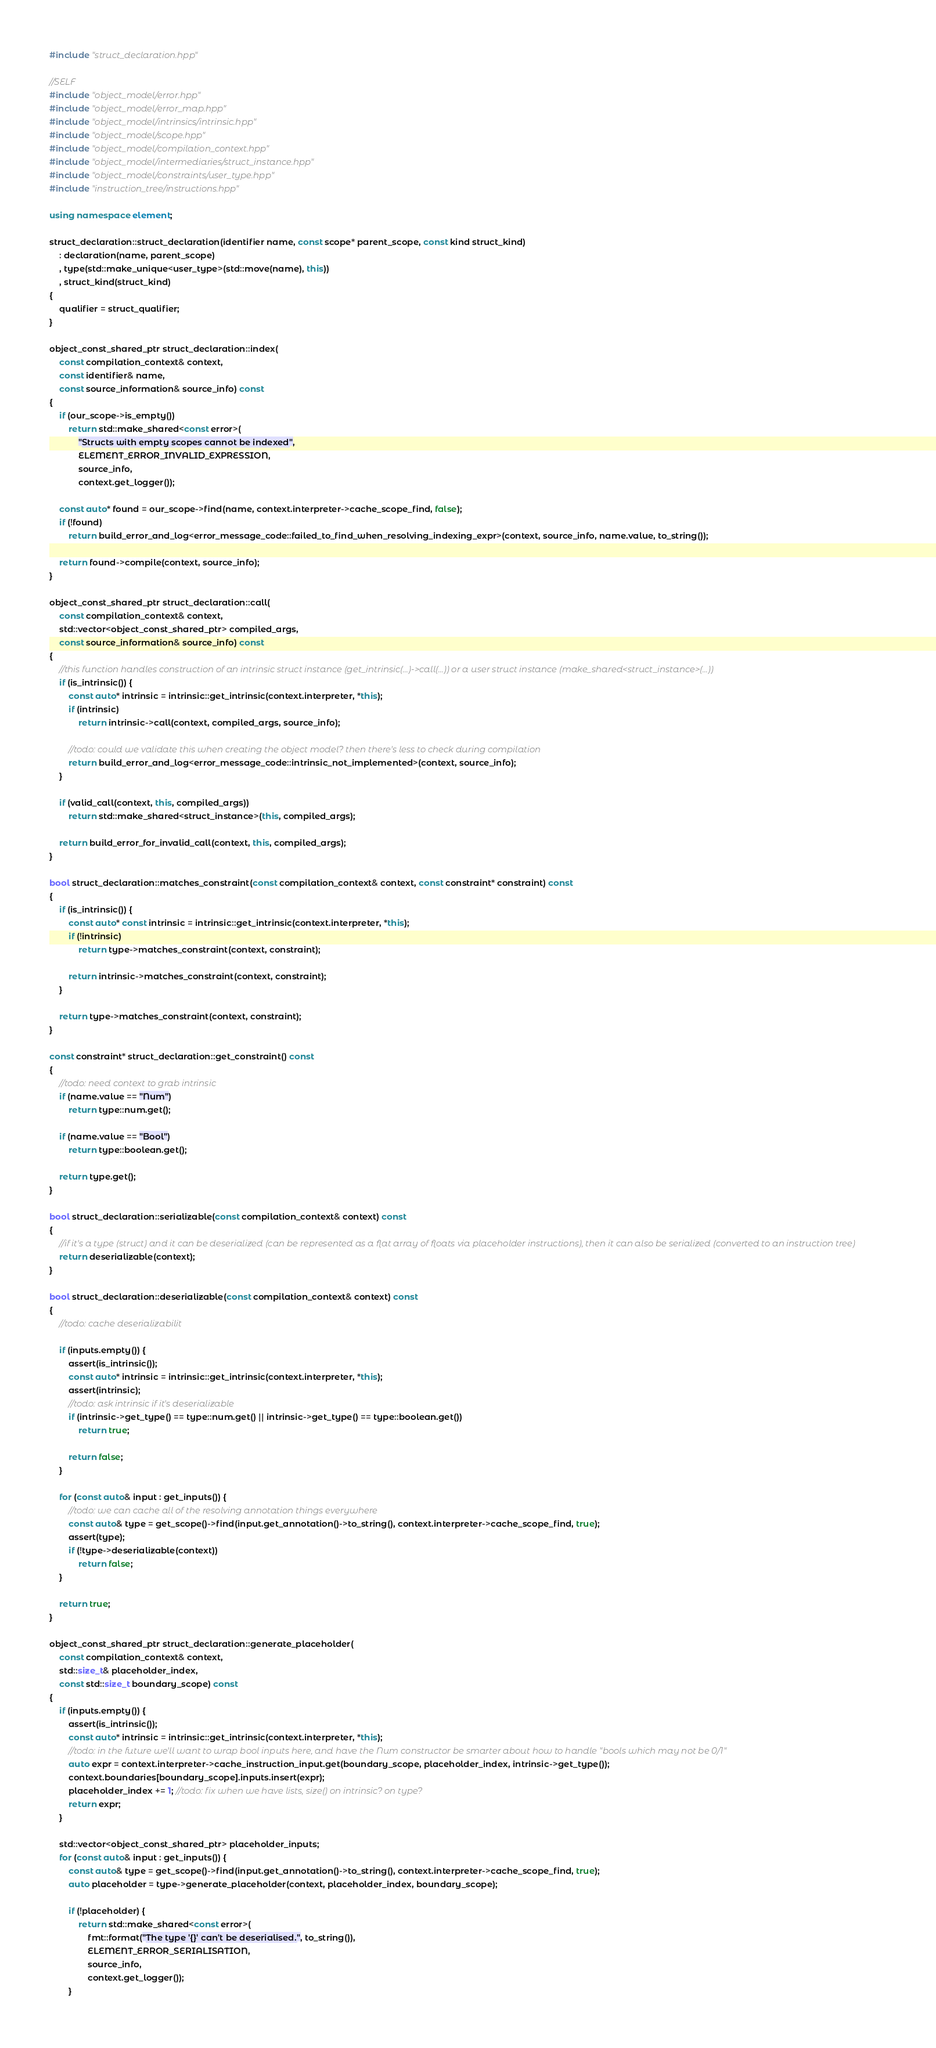Convert code to text. <code><loc_0><loc_0><loc_500><loc_500><_C++_>#include "struct_declaration.hpp"

//SELF
#include "object_model/error.hpp"
#include "object_model/error_map.hpp"
#include "object_model/intrinsics/intrinsic.hpp"
#include "object_model/scope.hpp"
#include "object_model/compilation_context.hpp"
#include "object_model/intermediaries/struct_instance.hpp"
#include "object_model/constraints/user_type.hpp"
#include "instruction_tree/instructions.hpp"

using namespace element;

struct_declaration::struct_declaration(identifier name, const scope* parent_scope, const kind struct_kind)
    : declaration(name, parent_scope)
    , type(std::make_unique<user_type>(std::move(name), this))
    , struct_kind(struct_kind)
{
    qualifier = struct_qualifier;
}

object_const_shared_ptr struct_declaration::index(
    const compilation_context& context,
    const identifier& name,
    const source_information& source_info) const
{
    if (our_scope->is_empty())
        return std::make_shared<const error>(
            "Structs with empty scopes cannot be indexed",
            ELEMENT_ERROR_INVALID_EXPRESSION,
            source_info,
            context.get_logger());

    const auto* found = our_scope->find(name, context.interpreter->cache_scope_find, false);
    if (!found)
        return build_error_and_log<error_message_code::failed_to_find_when_resolving_indexing_expr>(context, source_info, name.value, to_string());

    return found->compile(context, source_info);
}

object_const_shared_ptr struct_declaration::call(
    const compilation_context& context,
    std::vector<object_const_shared_ptr> compiled_args,
    const source_information& source_info) const
{
    //this function handles construction of an intrinsic struct instance (get_intrinsic(...)->call(...)) or a user struct instance (make_shared<struct_instance>(...))
    if (is_intrinsic()) {
        const auto* intrinsic = intrinsic::get_intrinsic(context.interpreter, *this);
        if (intrinsic)
            return intrinsic->call(context, compiled_args, source_info);

        //todo: could we validate this when creating the object model? then there's less to check during compilation
        return build_error_and_log<error_message_code::intrinsic_not_implemented>(context, source_info);
    }

    if (valid_call(context, this, compiled_args))
        return std::make_shared<struct_instance>(this, compiled_args);

    return build_error_for_invalid_call(context, this, compiled_args);
}

bool struct_declaration::matches_constraint(const compilation_context& context, const constraint* constraint) const
{
    if (is_intrinsic()) {
        const auto* const intrinsic = intrinsic::get_intrinsic(context.interpreter, *this);
        if (!intrinsic)
            return type->matches_constraint(context, constraint);

        return intrinsic->matches_constraint(context, constraint);
    }

    return type->matches_constraint(context, constraint);
}

const constraint* struct_declaration::get_constraint() const
{
    //todo: need context to grab intrinsic
    if (name.value == "Num")
        return type::num.get();

    if (name.value == "Bool")
        return type::boolean.get();

    return type.get();
}

bool struct_declaration::serializable(const compilation_context& context) const
{
    //if it's a type (struct) and it can be deserialized (can be represented as a flat array of floats via placeholder instructions), then it can also be serialized (converted to an instruction tree)
    return deserializable(context);
}

bool struct_declaration::deserializable(const compilation_context& context) const
{
    //todo: cache deserializabilit

    if (inputs.empty()) {
        assert(is_intrinsic());
        const auto* intrinsic = intrinsic::get_intrinsic(context.interpreter, *this);
        assert(intrinsic);
        //todo: ask intrinsic if it's deserializable
        if (intrinsic->get_type() == type::num.get() || intrinsic->get_type() == type::boolean.get())
            return true;

        return false;
    }

    for (const auto& input : get_inputs()) {
        //todo: we can cache all of the resolving annotation things everywhere
        const auto& type = get_scope()->find(input.get_annotation()->to_string(), context.interpreter->cache_scope_find, true);
        assert(type);
        if (!type->deserializable(context))
            return false;
    }

    return true;
}

object_const_shared_ptr struct_declaration::generate_placeholder(
    const compilation_context& context,
    std::size_t& placeholder_index,
    const std::size_t boundary_scope) const
{
    if (inputs.empty()) {
        assert(is_intrinsic());
        const auto* intrinsic = intrinsic::get_intrinsic(context.interpreter, *this);
        //todo: in the future we'll want to wrap bool inputs here, and have the Num constructor be smarter about how to handle "bools which may not be 0/1"
        auto expr = context.interpreter->cache_instruction_input.get(boundary_scope, placeholder_index, intrinsic->get_type());
        context.boundaries[boundary_scope].inputs.insert(expr);
        placeholder_index += 1; //todo: fix when we have lists, size() on intrinsic? on type?
        return expr;
    }

    std::vector<object_const_shared_ptr> placeholder_inputs;
    for (const auto& input : get_inputs()) {
        const auto& type = get_scope()->find(input.get_annotation()->to_string(), context.interpreter->cache_scope_find, true);
        auto placeholder = type->generate_placeholder(context, placeholder_index, boundary_scope);

        if (!placeholder) {
            return std::make_shared<const error>(
                fmt::format("The type '{}' can't be deserialised.", to_string()),
                ELEMENT_ERROR_SERIALISATION,
                source_info,
                context.get_logger());
        }
</code> 